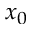Convert formula to latex. <formula><loc_0><loc_0><loc_500><loc_500>x _ { 0 }</formula> 